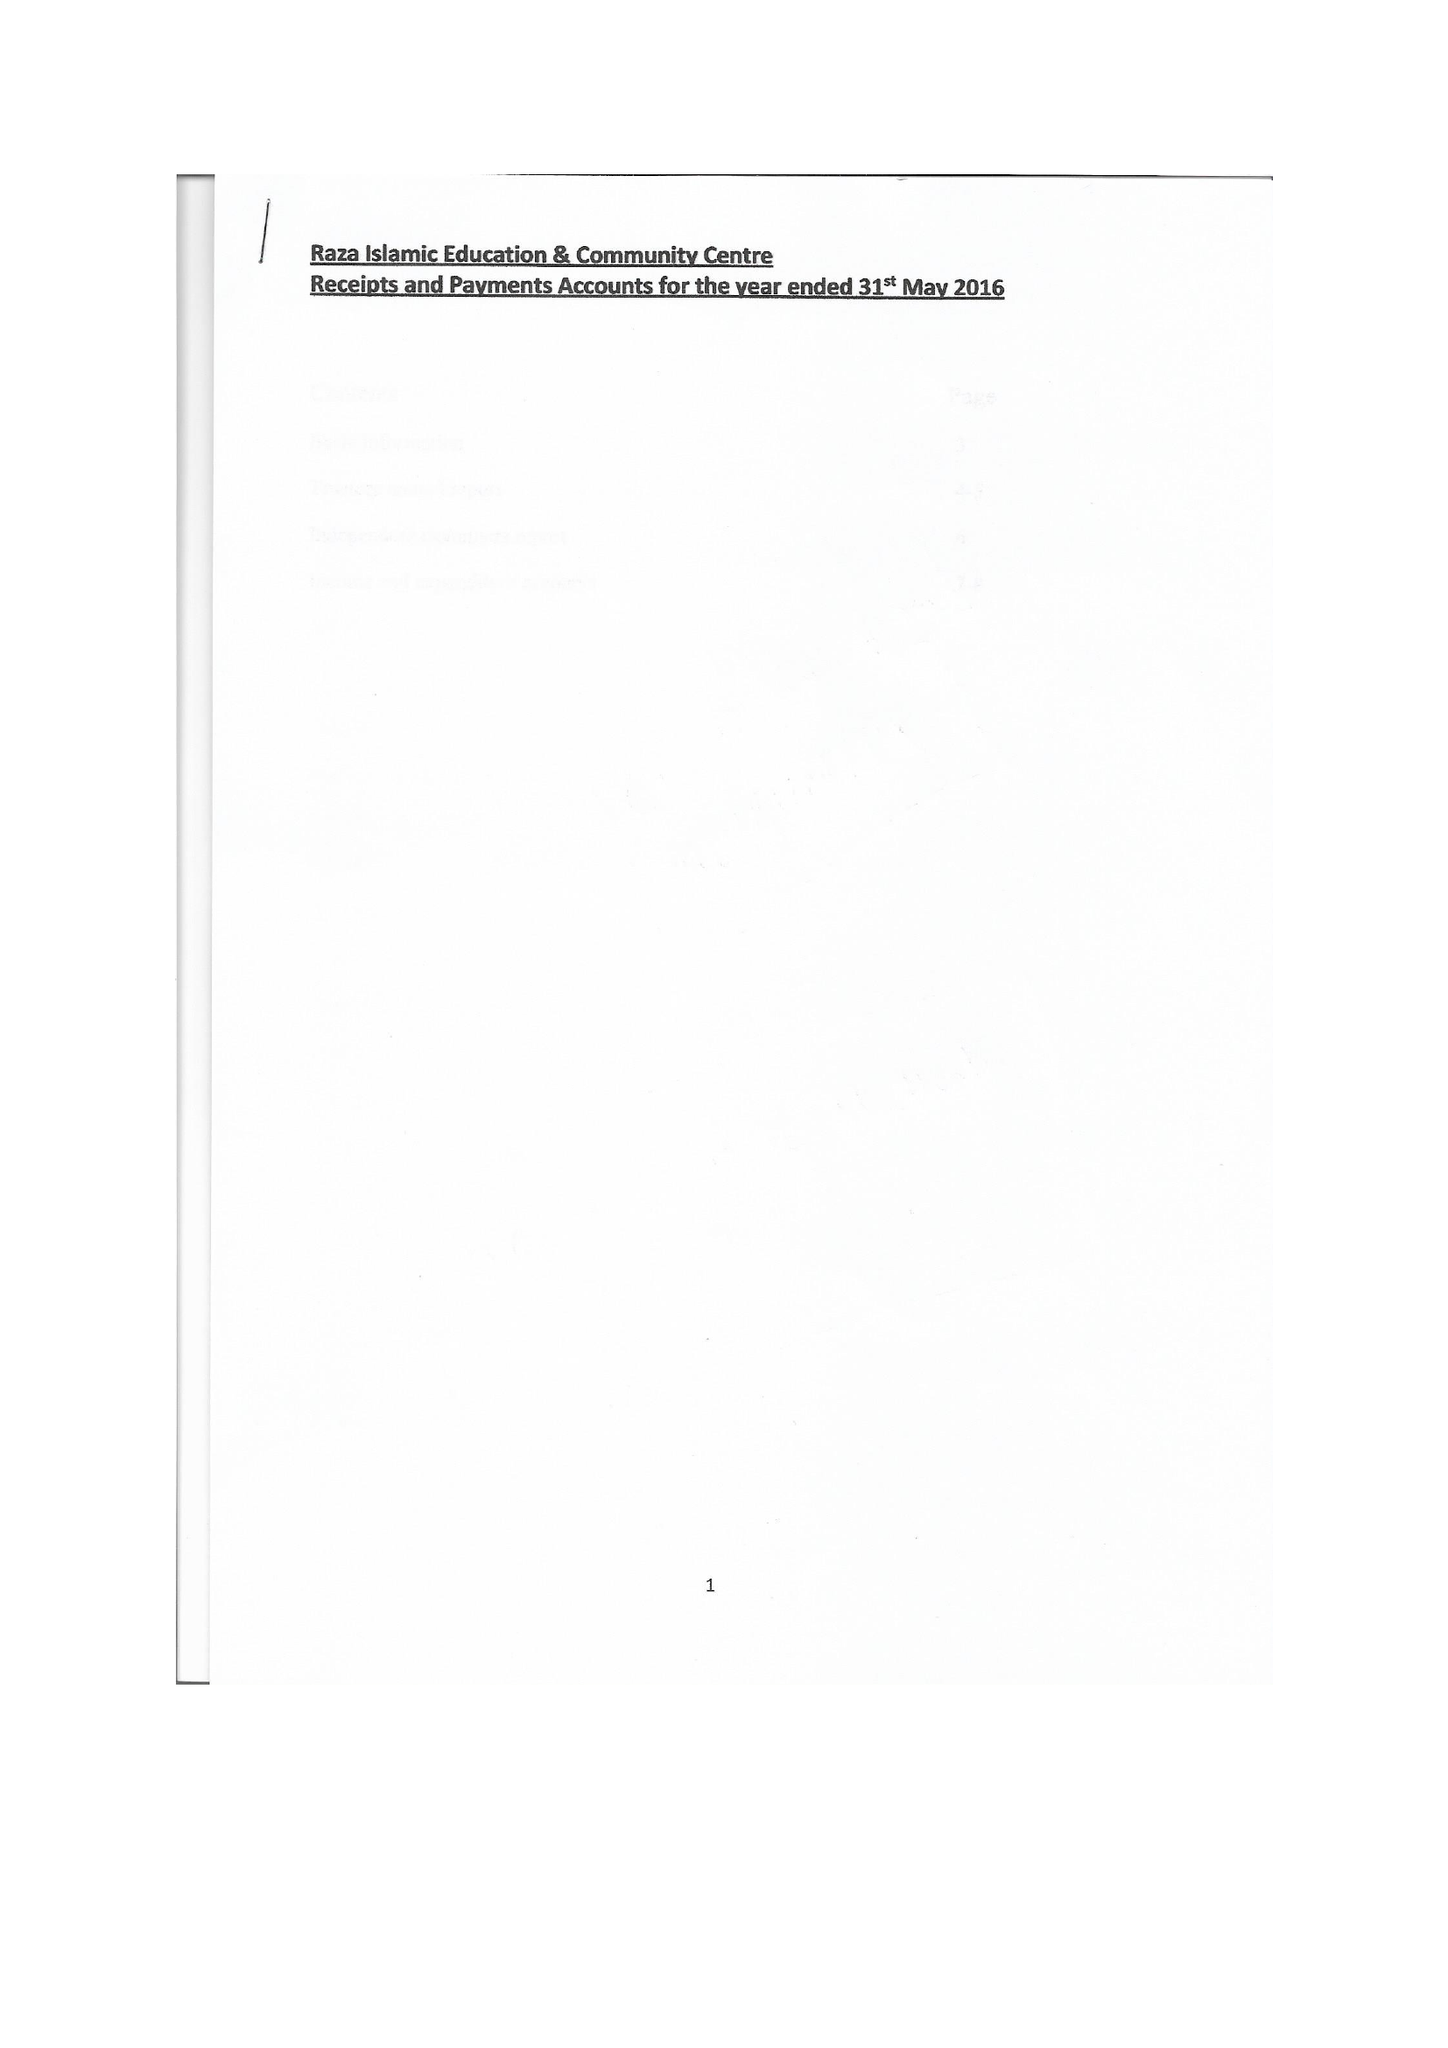What is the value for the address__postcode?
Answer the question using a single word or phrase. WF12 9HB 